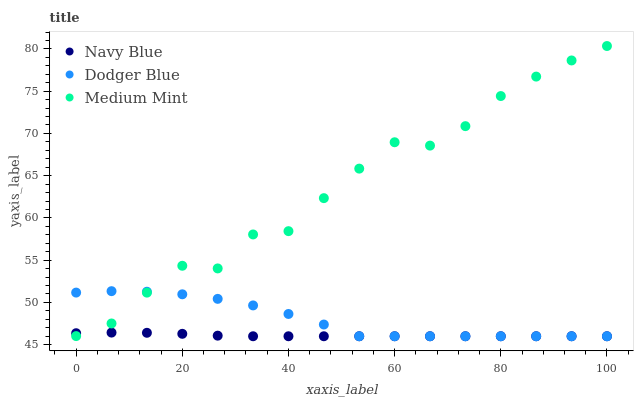Does Navy Blue have the minimum area under the curve?
Answer yes or no. Yes. Does Medium Mint have the maximum area under the curve?
Answer yes or no. Yes. Does Dodger Blue have the minimum area under the curve?
Answer yes or no. No. Does Dodger Blue have the maximum area under the curve?
Answer yes or no. No. Is Navy Blue the smoothest?
Answer yes or no. Yes. Is Medium Mint the roughest?
Answer yes or no. Yes. Is Dodger Blue the smoothest?
Answer yes or no. No. Is Dodger Blue the roughest?
Answer yes or no. No. Does Navy Blue have the lowest value?
Answer yes or no. Yes. Does Medium Mint have the highest value?
Answer yes or no. Yes. Does Dodger Blue have the highest value?
Answer yes or no. No. Does Navy Blue intersect Dodger Blue?
Answer yes or no. Yes. Is Navy Blue less than Dodger Blue?
Answer yes or no. No. Is Navy Blue greater than Dodger Blue?
Answer yes or no. No. 